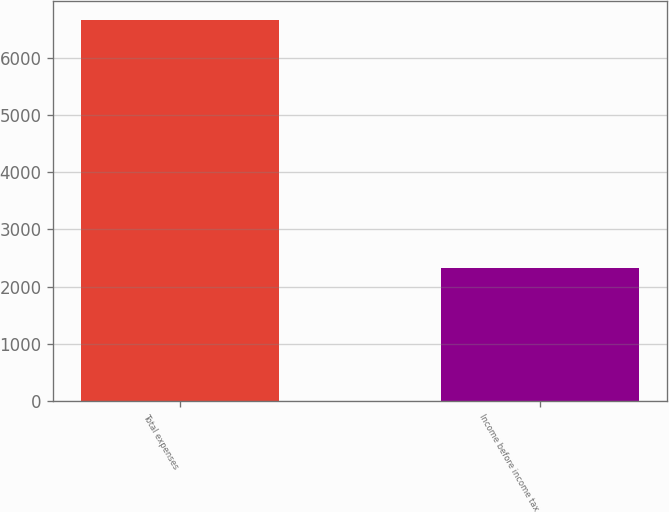<chart> <loc_0><loc_0><loc_500><loc_500><bar_chart><fcel>Total expenses<fcel>Income before income tax<nl><fcel>6648<fcel>2318<nl></chart> 